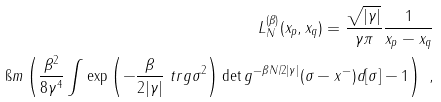Convert formula to latex. <formula><loc_0><loc_0><loc_500><loc_500>L _ { N } ^ { ( \beta ) } ( x _ { p } , x _ { q } ) = \frac { \sqrt { | \gamma | } } { \gamma \pi } \frac { 1 } { x _ { p } - x _ { q } } \\ \ \i m \left ( \frac { \beta ^ { 2 } } { 8 \gamma ^ { 4 } } \int \exp \left ( - \frac { \beta } { 2 | \gamma | } \ t r g \sigma ^ { 2 } \right ) \det g ^ { - \beta N / 2 | \gamma | } ( \sigma - x ^ { - } ) d [ \sigma ] - 1 \right ) \ ,</formula> 